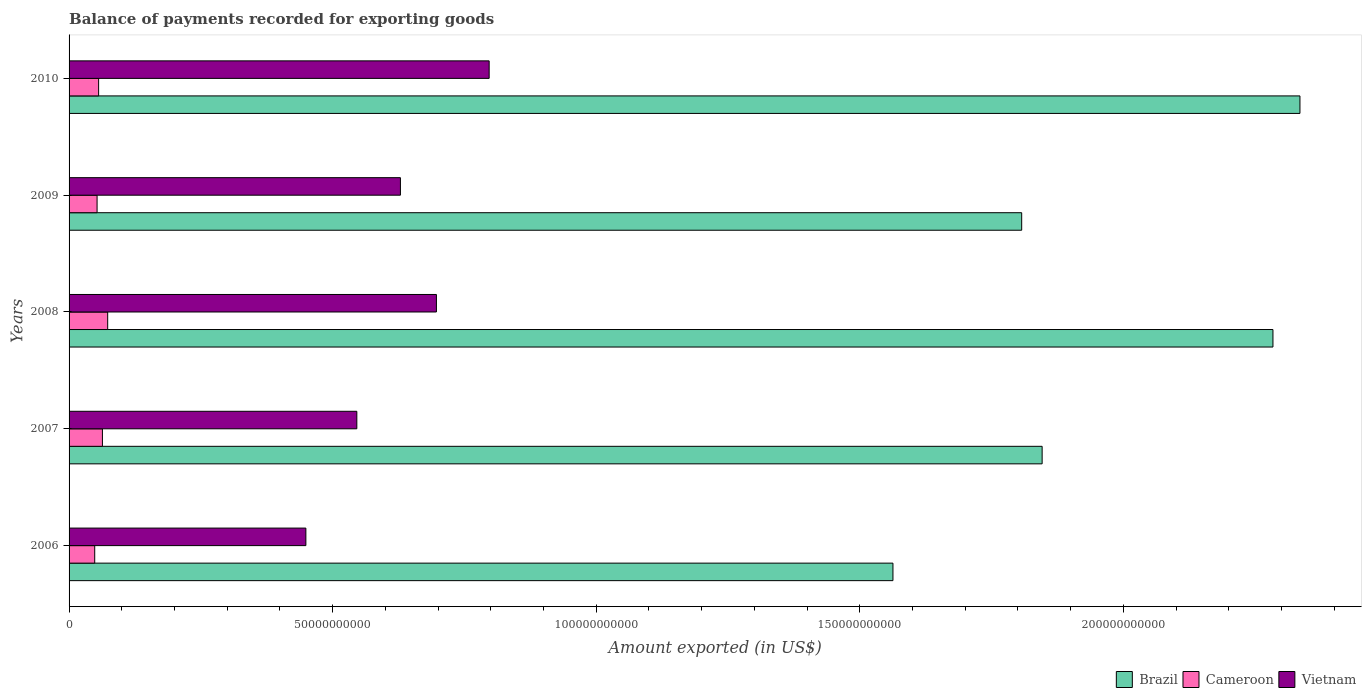How many groups of bars are there?
Your answer should be compact. 5. Are the number of bars per tick equal to the number of legend labels?
Provide a succinct answer. Yes. Are the number of bars on each tick of the Y-axis equal?
Offer a very short reply. Yes. How many bars are there on the 2nd tick from the bottom?
Ensure brevity in your answer.  3. What is the label of the 3rd group of bars from the top?
Your answer should be compact. 2008. What is the amount exported in Vietnam in 2008?
Offer a very short reply. 6.97e+1. Across all years, what is the maximum amount exported in Brazil?
Your response must be concise. 2.34e+11. Across all years, what is the minimum amount exported in Brazil?
Ensure brevity in your answer.  1.56e+11. In which year was the amount exported in Vietnam minimum?
Provide a succinct answer. 2006. What is the total amount exported in Cameroon in the graph?
Your answer should be compact. 2.94e+1. What is the difference between the amount exported in Vietnam in 2008 and that in 2009?
Give a very brief answer. 6.83e+09. What is the difference between the amount exported in Brazil in 2009 and the amount exported in Cameroon in 2008?
Your answer should be compact. 1.73e+11. What is the average amount exported in Cameroon per year?
Give a very brief answer. 5.89e+09. In the year 2006, what is the difference between the amount exported in Vietnam and amount exported in Brazil?
Your answer should be compact. -1.11e+11. In how many years, is the amount exported in Cameroon greater than 190000000000 US$?
Your answer should be very brief. 0. What is the ratio of the amount exported in Brazil in 2006 to that in 2009?
Keep it short and to the point. 0.86. Is the amount exported in Brazil in 2009 less than that in 2010?
Your answer should be compact. Yes. Is the difference between the amount exported in Vietnam in 2006 and 2010 greater than the difference between the amount exported in Brazil in 2006 and 2010?
Your response must be concise. Yes. What is the difference between the highest and the second highest amount exported in Cameroon?
Provide a short and direct response. 9.99e+08. What is the difference between the highest and the lowest amount exported in Brazil?
Offer a terse response. 7.72e+1. What does the 2nd bar from the bottom in 2009 represents?
Offer a terse response. Cameroon. Is it the case that in every year, the sum of the amount exported in Vietnam and amount exported in Brazil is greater than the amount exported in Cameroon?
Ensure brevity in your answer.  Yes. Are all the bars in the graph horizontal?
Your response must be concise. Yes. How many years are there in the graph?
Keep it short and to the point. 5. Where does the legend appear in the graph?
Keep it short and to the point. Bottom right. How many legend labels are there?
Give a very brief answer. 3. How are the legend labels stacked?
Provide a short and direct response. Horizontal. What is the title of the graph?
Ensure brevity in your answer.  Balance of payments recorded for exporting goods. Does "Middle East & North Africa (all income levels)" appear as one of the legend labels in the graph?
Offer a very short reply. No. What is the label or title of the X-axis?
Make the answer very short. Amount exported (in US$). What is the label or title of the Y-axis?
Keep it short and to the point. Years. What is the Amount exported (in US$) of Brazil in 2006?
Keep it short and to the point. 1.56e+11. What is the Amount exported (in US$) of Cameroon in 2006?
Make the answer very short. 4.87e+09. What is the Amount exported (in US$) in Vietnam in 2006?
Ensure brevity in your answer.  4.49e+1. What is the Amount exported (in US$) in Brazil in 2007?
Offer a terse response. 1.85e+11. What is the Amount exported (in US$) of Cameroon in 2007?
Your answer should be compact. 6.33e+09. What is the Amount exported (in US$) of Vietnam in 2007?
Provide a succinct answer. 5.46e+1. What is the Amount exported (in US$) in Brazil in 2008?
Ensure brevity in your answer.  2.28e+11. What is the Amount exported (in US$) of Cameroon in 2008?
Offer a terse response. 7.33e+09. What is the Amount exported (in US$) of Vietnam in 2008?
Your response must be concise. 6.97e+1. What is the Amount exported (in US$) in Brazil in 2009?
Give a very brief answer. 1.81e+11. What is the Amount exported (in US$) of Cameroon in 2009?
Offer a very short reply. 5.31e+09. What is the Amount exported (in US$) in Vietnam in 2009?
Provide a short and direct response. 6.29e+1. What is the Amount exported (in US$) in Brazil in 2010?
Provide a short and direct response. 2.34e+11. What is the Amount exported (in US$) of Cameroon in 2010?
Keep it short and to the point. 5.61e+09. What is the Amount exported (in US$) in Vietnam in 2010?
Offer a very short reply. 7.97e+1. Across all years, what is the maximum Amount exported (in US$) of Brazil?
Your answer should be very brief. 2.34e+11. Across all years, what is the maximum Amount exported (in US$) in Cameroon?
Keep it short and to the point. 7.33e+09. Across all years, what is the maximum Amount exported (in US$) of Vietnam?
Ensure brevity in your answer.  7.97e+1. Across all years, what is the minimum Amount exported (in US$) of Brazil?
Your answer should be compact. 1.56e+11. Across all years, what is the minimum Amount exported (in US$) in Cameroon?
Make the answer very short. 4.87e+09. Across all years, what is the minimum Amount exported (in US$) in Vietnam?
Keep it short and to the point. 4.49e+1. What is the total Amount exported (in US$) of Brazil in the graph?
Your answer should be very brief. 9.84e+11. What is the total Amount exported (in US$) in Cameroon in the graph?
Your response must be concise. 2.94e+1. What is the total Amount exported (in US$) in Vietnam in the graph?
Make the answer very short. 3.12e+11. What is the difference between the Amount exported (in US$) of Brazil in 2006 and that in 2007?
Make the answer very short. -2.83e+1. What is the difference between the Amount exported (in US$) of Cameroon in 2006 and that in 2007?
Offer a very short reply. -1.46e+09. What is the difference between the Amount exported (in US$) of Vietnam in 2006 and that in 2007?
Your answer should be compact. -9.66e+09. What is the difference between the Amount exported (in US$) of Brazil in 2006 and that in 2008?
Your answer should be compact. -7.21e+1. What is the difference between the Amount exported (in US$) of Cameroon in 2006 and that in 2008?
Make the answer very short. -2.46e+09. What is the difference between the Amount exported (in US$) of Vietnam in 2006 and that in 2008?
Ensure brevity in your answer.  -2.48e+1. What is the difference between the Amount exported (in US$) of Brazil in 2006 and that in 2009?
Keep it short and to the point. -2.44e+1. What is the difference between the Amount exported (in US$) of Cameroon in 2006 and that in 2009?
Offer a very short reply. -4.48e+08. What is the difference between the Amount exported (in US$) of Vietnam in 2006 and that in 2009?
Offer a very short reply. -1.79e+1. What is the difference between the Amount exported (in US$) of Brazil in 2006 and that in 2010?
Make the answer very short. -7.72e+1. What is the difference between the Amount exported (in US$) in Cameroon in 2006 and that in 2010?
Provide a short and direct response. -7.43e+08. What is the difference between the Amount exported (in US$) of Vietnam in 2006 and that in 2010?
Provide a short and direct response. -3.48e+1. What is the difference between the Amount exported (in US$) of Brazil in 2007 and that in 2008?
Provide a short and direct response. -4.38e+1. What is the difference between the Amount exported (in US$) in Cameroon in 2007 and that in 2008?
Offer a very short reply. -9.99e+08. What is the difference between the Amount exported (in US$) in Vietnam in 2007 and that in 2008?
Offer a terse response. -1.51e+1. What is the difference between the Amount exported (in US$) of Brazil in 2007 and that in 2009?
Provide a short and direct response. 3.88e+09. What is the difference between the Amount exported (in US$) in Cameroon in 2007 and that in 2009?
Keep it short and to the point. 1.01e+09. What is the difference between the Amount exported (in US$) of Vietnam in 2007 and that in 2009?
Make the answer very short. -8.27e+09. What is the difference between the Amount exported (in US$) of Brazil in 2007 and that in 2010?
Ensure brevity in your answer.  -4.89e+1. What is the difference between the Amount exported (in US$) in Cameroon in 2007 and that in 2010?
Your answer should be compact. 7.18e+08. What is the difference between the Amount exported (in US$) of Vietnam in 2007 and that in 2010?
Keep it short and to the point. -2.51e+1. What is the difference between the Amount exported (in US$) of Brazil in 2008 and that in 2009?
Provide a short and direct response. 4.77e+1. What is the difference between the Amount exported (in US$) in Cameroon in 2008 and that in 2009?
Offer a very short reply. 2.01e+09. What is the difference between the Amount exported (in US$) in Vietnam in 2008 and that in 2009?
Provide a succinct answer. 6.83e+09. What is the difference between the Amount exported (in US$) in Brazil in 2008 and that in 2010?
Offer a very short reply. -5.12e+09. What is the difference between the Amount exported (in US$) in Cameroon in 2008 and that in 2010?
Ensure brevity in your answer.  1.72e+09. What is the difference between the Amount exported (in US$) in Vietnam in 2008 and that in 2010?
Your answer should be very brief. -1.00e+1. What is the difference between the Amount exported (in US$) of Brazil in 2009 and that in 2010?
Offer a very short reply. -5.28e+1. What is the difference between the Amount exported (in US$) of Cameroon in 2009 and that in 2010?
Your answer should be compact. -2.95e+08. What is the difference between the Amount exported (in US$) in Vietnam in 2009 and that in 2010?
Keep it short and to the point. -1.68e+1. What is the difference between the Amount exported (in US$) of Brazil in 2006 and the Amount exported (in US$) of Cameroon in 2007?
Offer a terse response. 1.50e+11. What is the difference between the Amount exported (in US$) in Brazil in 2006 and the Amount exported (in US$) in Vietnam in 2007?
Your answer should be compact. 1.02e+11. What is the difference between the Amount exported (in US$) of Cameroon in 2006 and the Amount exported (in US$) of Vietnam in 2007?
Your response must be concise. -4.97e+1. What is the difference between the Amount exported (in US$) of Brazil in 2006 and the Amount exported (in US$) of Cameroon in 2008?
Offer a terse response. 1.49e+11. What is the difference between the Amount exported (in US$) of Brazil in 2006 and the Amount exported (in US$) of Vietnam in 2008?
Your answer should be compact. 8.66e+1. What is the difference between the Amount exported (in US$) in Cameroon in 2006 and the Amount exported (in US$) in Vietnam in 2008?
Provide a short and direct response. -6.48e+1. What is the difference between the Amount exported (in US$) of Brazil in 2006 and the Amount exported (in US$) of Cameroon in 2009?
Provide a succinct answer. 1.51e+11. What is the difference between the Amount exported (in US$) in Brazil in 2006 and the Amount exported (in US$) in Vietnam in 2009?
Make the answer very short. 9.34e+1. What is the difference between the Amount exported (in US$) of Cameroon in 2006 and the Amount exported (in US$) of Vietnam in 2009?
Provide a short and direct response. -5.80e+1. What is the difference between the Amount exported (in US$) of Brazil in 2006 and the Amount exported (in US$) of Cameroon in 2010?
Your response must be concise. 1.51e+11. What is the difference between the Amount exported (in US$) in Brazil in 2006 and the Amount exported (in US$) in Vietnam in 2010?
Your answer should be very brief. 7.66e+1. What is the difference between the Amount exported (in US$) of Cameroon in 2006 and the Amount exported (in US$) of Vietnam in 2010?
Your response must be concise. -7.48e+1. What is the difference between the Amount exported (in US$) of Brazil in 2007 and the Amount exported (in US$) of Cameroon in 2008?
Your response must be concise. 1.77e+11. What is the difference between the Amount exported (in US$) in Brazil in 2007 and the Amount exported (in US$) in Vietnam in 2008?
Give a very brief answer. 1.15e+11. What is the difference between the Amount exported (in US$) of Cameroon in 2007 and the Amount exported (in US$) of Vietnam in 2008?
Keep it short and to the point. -6.34e+1. What is the difference between the Amount exported (in US$) of Brazil in 2007 and the Amount exported (in US$) of Cameroon in 2009?
Make the answer very short. 1.79e+11. What is the difference between the Amount exported (in US$) in Brazil in 2007 and the Amount exported (in US$) in Vietnam in 2009?
Provide a succinct answer. 1.22e+11. What is the difference between the Amount exported (in US$) of Cameroon in 2007 and the Amount exported (in US$) of Vietnam in 2009?
Offer a terse response. -5.65e+1. What is the difference between the Amount exported (in US$) of Brazil in 2007 and the Amount exported (in US$) of Cameroon in 2010?
Keep it short and to the point. 1.79e+11. What is the difference between the Amount exported (in US$) of Brazil in 2007 and the Amount exported (in US$) of Vietnam in 2010?
Make the answer very short. 1.05e+11. What is the difference between the Amount exported (in US$) in Cameroon in 2007 and the Amount exported (in US$) in Vietnam in 2010?
Provide a short and direct response. -7.34e+1. What is the difference between the Amount exported (in US$) of Brazil in 2008 and the Amount exported (in US$) of Cameroon in 2009?
Keep it short and to the point. 2.23e+11. What is the difference between the Amount exported (in US$) of Brazil in 2008 and the Amount exported (in US$) of Vietnam in 2009?
Ensure brevity in your answer.  1.66e+11. What is the difference between the Amount exported (in US$) in Cameroon in 2008 and the Amount exported (in US$) in Vietnam in 2009?
Make the answer very short. -5.55e+1. What is the difference between the Amount exported (in US$) in Brazil in 2008 and the Amount exported (in US$) in Cameroon in 2010?
Your response must be concise. 2.23e+11. What is the difference between the Amount exported (in US$) in Brazil in 2008 and the Amount exported (in US$) in Vietnam in 2010?
Offer a terse response. 1.49e+11. What is the difference between the Amount exported (in US$) of Cameroon in 2008 and the Amount exported (in US$) of Vietnam in 2010?
Ensure brevity in your answer.  -7.24e+1. What is the difference between the Amount exported (in US$) of Brazil in 2009 and the Amount exported (in US$) of Cameroon in 2010?
Ensure brevity in your answer.  1.75e+11. What is the difference between the Amount exported (in US$) of Brazil in 2009 and the Amount exported (in US$) of Vietnam in 2010?
Ensure brevity in your answer.  1.01e+11. What is the difference between the Amount exported (in US$) in Cameroon in 2009 and the Amount exported (in US$) in Vietnam in 2010?
Provide a succinct answer. -7.44e+1. What is the average Amount exported (in US$) in Brazil per year?
Your answer should be very brief. 1.97e+11. What is the average Amount exported (in US$) in Cameroon per year?
Give a very brief answer. 5.89e+09. What is the average Amount exported (in US$) in Vietnam per year?
Your answer should be compact. 6.24e+1. In the year 2006, what is the difference between the Amount exported (in US$) of Brazil and Amount exported (in US$) of Cameroon?
Provide a short and direct response. 1.51e+11. In the year 2006, what is the difference between the Amount exported (in US$) in Brazil and Amount exported (in US$) in Vietnam?
Ensure brevity in your answer.  1.11e+11. In the year 2006, what is the difference between the Amount exported (in US$) in Cameroon and Amount exported (in US$) in Vietnam?
Your answer should be very brief. -4.01e+1. In the year 2007, what is the difference between the Amount exported (in US$) in Brazil and Amount exported (in US$) in Cameroon?
Your answer should be compact. 1.78e+11. In the year 2007, what is the difference between the Amount exported (in US$) in Brazil and Amount exported (in US$) in Vietnam?
Keep it short and to the point. 1.30e+11. In the year 2007, what is the difference between the Amount exported (in US$) of Cameroon and Amount exported (in US$) of Vietnam?
Give a very brief answer. -4.83e+1. In the year 2008, what is the difference between the Amount exported (in US$) in Brazil and Amount exported (in US$) in Cameroon?
Your answer should be very brief. 2.21e+11. In the year 2008, what is the difference between the Amount exported (in US$) of Brazil and Amount exported (in US$) of Vietnam?
Offer a terse response. 1.59e+11. In the year 2008, what is the difference between the Amount exported (in US$) in Cameroon and Amount exported (in US$) in Vietnam?
Provide a short and direct response. -6.24e+1. In the year 2009, what is the difference between the Amount exported (in US$) of Brazil and Amount exported (in US$) of Cameroon?
Your answer should be very brief. 1.75e+11. In the year 2009, what is the difference between the Amount exported (in US$) of Brazil and Amount exported (in US$) of Vietnam?
Offer a terse response. 1.18e+11. In the year 2009, what is the difference between the Amount exported (in US$) of Cameroon and Amount exported (in US$) of Vietnam?
Provide a short and direct response. -5.75e+1. In the year 2010, what is the difference between the Amount exported (in US$) of Brazil and Amount exported (in US$) of Cameroon?
Your answer should be very brief. 2.28e+11. In the year 2010, what is the difference between the Amount exported (in US$) in Brazil and Amount exported (in US$) in Vietnam?
Your response must be concise. 1.54e+11. In the year 2010, what is the difference between the Amount exported (in US$) in Cameroon and Amount exported (in US$) in Vietnam?
Offer a very short reply. -7.41e+1. What is the ratio of the Amount exported (in US$) in Brazil in 2006 to that in 2007?
Ensure brevity in your answer.  0.85. What is the ratio of the Amount exported (in US$) of Cameroon in 2006 to that in 2007?
Provide a succinct answer. 0.77. What is the ratio of the Amount exported (in US$) of Vietnam in 2006 to that in 2007?
Your answer should be very brief. 0.82. What is the ratio of the Amount exported (in US$) in Brazil in 2006 to that in 2008?
Ensure brevity in your answer.  0.68. What is the ratio of the Amount exported (in US$) of Cameroon in 2006 to that in 2008?
Provide a succinct answer. 0.66. What is the ratio of the Amount exported (in US$) of Vietnam in 2006 to that in 2008?
Provide a short and direct response. 0.64. What is the ratio of the Amount exported (in US$) in Brazil in 2006 to that in 2009?
Offer a terse response. 0.86. What is the ratio of the Amount exported (in US$) of Cameroon in 2006 to that in 2009?
Ensure brevity in your answer.  0.92. What is the ratio of the Amount exported (in US$) of Vietnam in 2006 to that in 2009?
Offer a terse response. 0.71. What is the ratio of the Amount exported (in US$) in Brazil in 2006 to that in 2010?
Make the answer very short. 0.67. What is the ratio of the Amount exported (in US$) of Cameroon in 2006 to that in 2010?
Offer a terse response. 0.87. What is the ratio of the Amount exported (in US$) of Vietnam in 2006 to that in 2010?
Give a very brief answer. 0.56. What is the ratio of the Amount exported (in US$) of Brazil in 2007 to that in 2008?
Offer a very short reply. 0.81. What is the ratio of the Amount exported (in US$) of Cameroon in 2007 to that in 2008?
Make the answer very short. 0.86. What is the ratio of the Amount exported (in US$) in Vietnam in 2007 to that in 2008?
Your response must be concise. 0.78. What is the ratio of the Amount exported (in US$) in Brazil in 2007 to that in 2009?
Your response must be concise. 1.02. What is the ratio of the Amount exported (in US$) in Cameroon in 2007 to that in 2009?
Give a very brief answer. 1.19. What is the ratio of the Amount exported (in US$) of Vietnam in 2007 to that in 2009?
Make the answer very short. 0.87. What is the ratio of the Amount exported (in US$) of Brazil in 2007 to that in 2010?
Ensure brevity in your answer.  0.79. What is the ratio of the Amount exported (in US$) in Cameroon in 2007 to that in 2010?
Keep it short and to the point. 1.13. What is the ratio of the Amount exported (in US$) in Vietnam in 2007 to that in 2010?
Give a very brief answer. 0.69. What is the ratio of the Amount exported (in US$) of Brazil in 2008 to that in 2009?
Make the answer very short. 1.26. What is the ratio of the Amount exported (in US$) of Cameroon in 2008 to that in 2009?
Provide a short and direct response. 1.38. What is the ratio of the Amount exported (in US$) in Vietnam in 2008 to that in 2009?
Your answer should be very brief. 1.11. What is the ratio of the Amount exported (in US$) in Brazil in 2008 to that in 2010?
Ensure brevity in your answer.  0.98. What is the ratio of the Amount exported (in US$) in Cameroon in 2008 to that in 2010?
Offer a terse response. 1.31. What is the ratio of the Amount exported (in US$) in Vietnam in 2008 to that in 2010?
Your answer should be very brief. 0.87. What is the ratio of the Amount exported (in US$) in Brazil in 2009 to that in 2010?
Your answer should be very brief. 0.77. What is the ratio of the Amount exported (in US$) of Cameroon in 2009 to that in 2010?
Your answer should be very brief. 0.95. What is the ratio of the Amount exported (in US$) in Vietnam in 2009 to that in 2010?
Offer a terse response. 0.79. What is the difference between the highest and the second highest Amount exported (in US$) of Brazil?
Your response must be concise. 5.12e+09. What is the difference between the highest and the second highest Amount exported (in US$) in Cameroon?
Offer a very short reply. 9.99e+08. What is the difference between the highest and the second highest Amount exported (in US$) in Vietnam?
Ensure brevity in your answer.  1.00e+1. What is the difference between the highest and the lowest Amount exported (in US$) of Brazil?
Provide a short and direct response. 7.72e+1. What is the difference between the highest and the lowest Amount exported (in US$) of Cameroon?
Provide a short and direct response. 2.46e+09. What is the difference between the highest and the lowest Amount exported (in US$) of Vietnam?
Provide a succinct answer. 3.48e+1. 